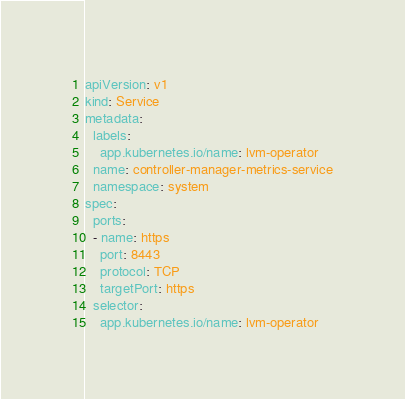Convert code to text. <code><loc_0><loc_0><loc_500><loc_500><_YAML_>apiVersion: v1
kind: Service
metadata:
  labels:
    app.kubernetes.io/name: lvm-operator
  name: controller-manager-metrics-service
  namespace: system
spec:
  ports:
  - name: https
    port: 8443
    protocol: TCP
    targetPort: https
  selector:
    app.kubernetes.io/name: lvm-operator
</code> 